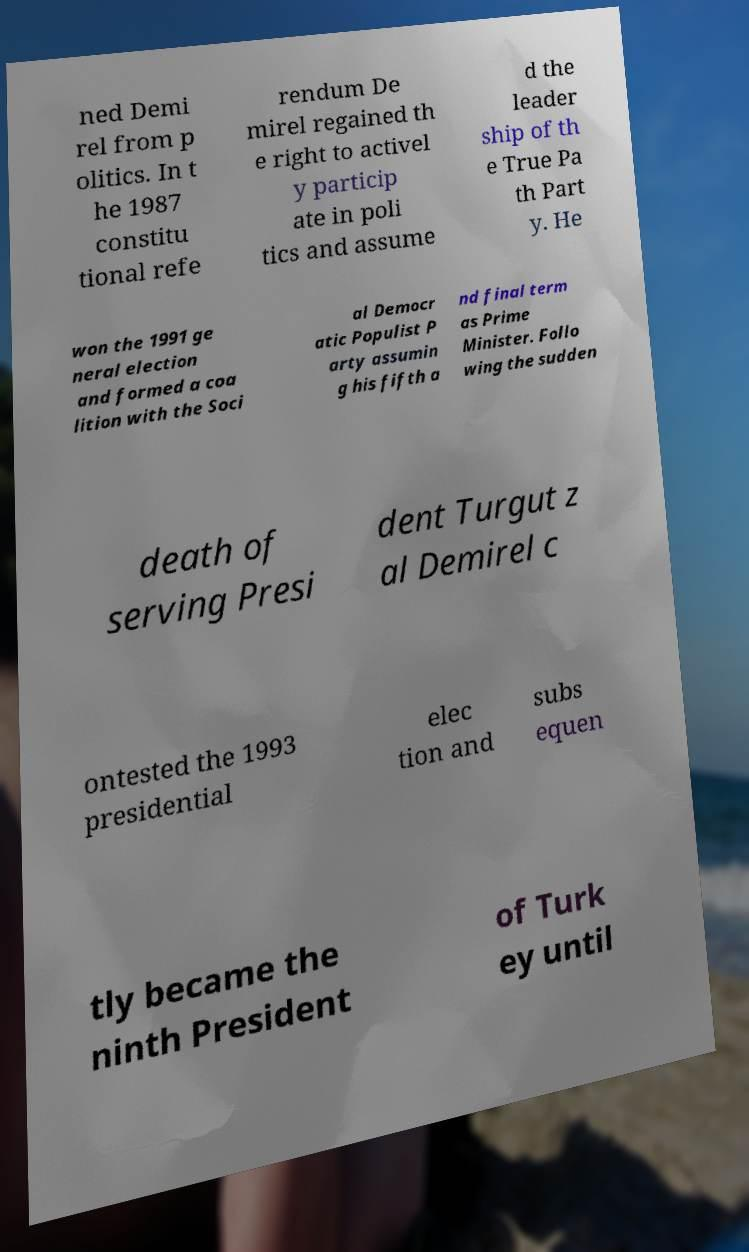There's text embedded in this image that I need extracted. Can you transcribe it verbatim? ned Demi rel from p olitics. In t he 1987 constitu tional refe rendum De mirel regained th e right to activel y particip ate in poli tics and assume d the leader ship of th e True Pa th Part y. He won the 1991 ge neral election and formed a coa lition with the Soci al Democr atic Populist P arty assumin g his fifth a nd final term as Prime Minister. Follo wing the sudden death of serving Presi dent Turgut z al Demirel c ontested the 1993 presidential elec tion and subs equen tly became the ninth President of Turk ey until 